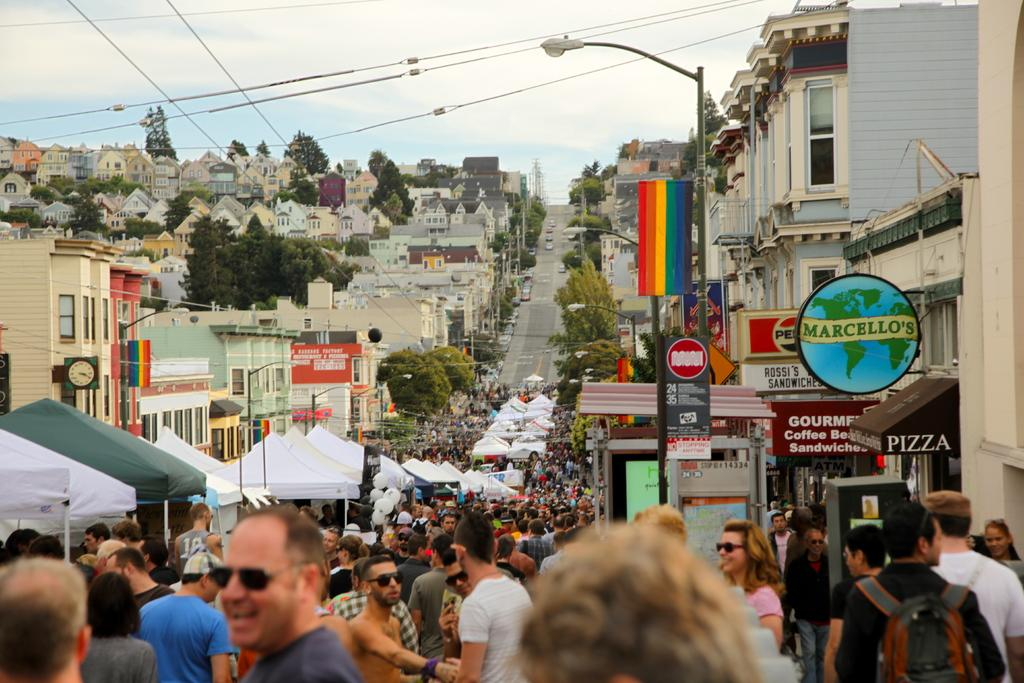Who or what can be seen in the image? There are people in the image. What else is present in the image besides people? There are vehicles on the road and houses on the left and right sides of the image. What is visible in the sky at the top of the image? Clouds are visible in the sky at the top of the image. What type of fiction is being read by the people in the image? There is no indication in the image that the people are reading any fiction, as the focus is on the people, vehicles, houses, and clouds. 